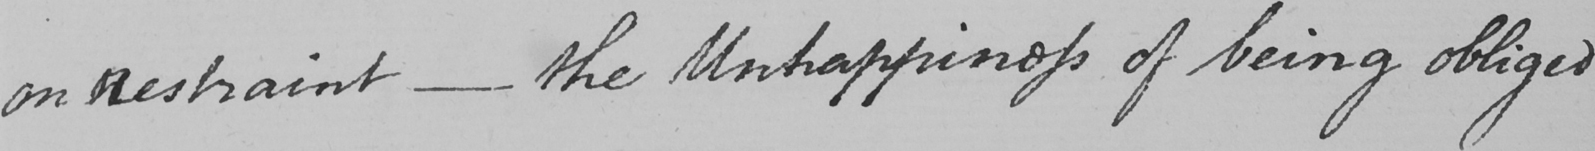Please provide the text content of this handwritten line. on Restraint  _  the Unhappiness of being obliged 